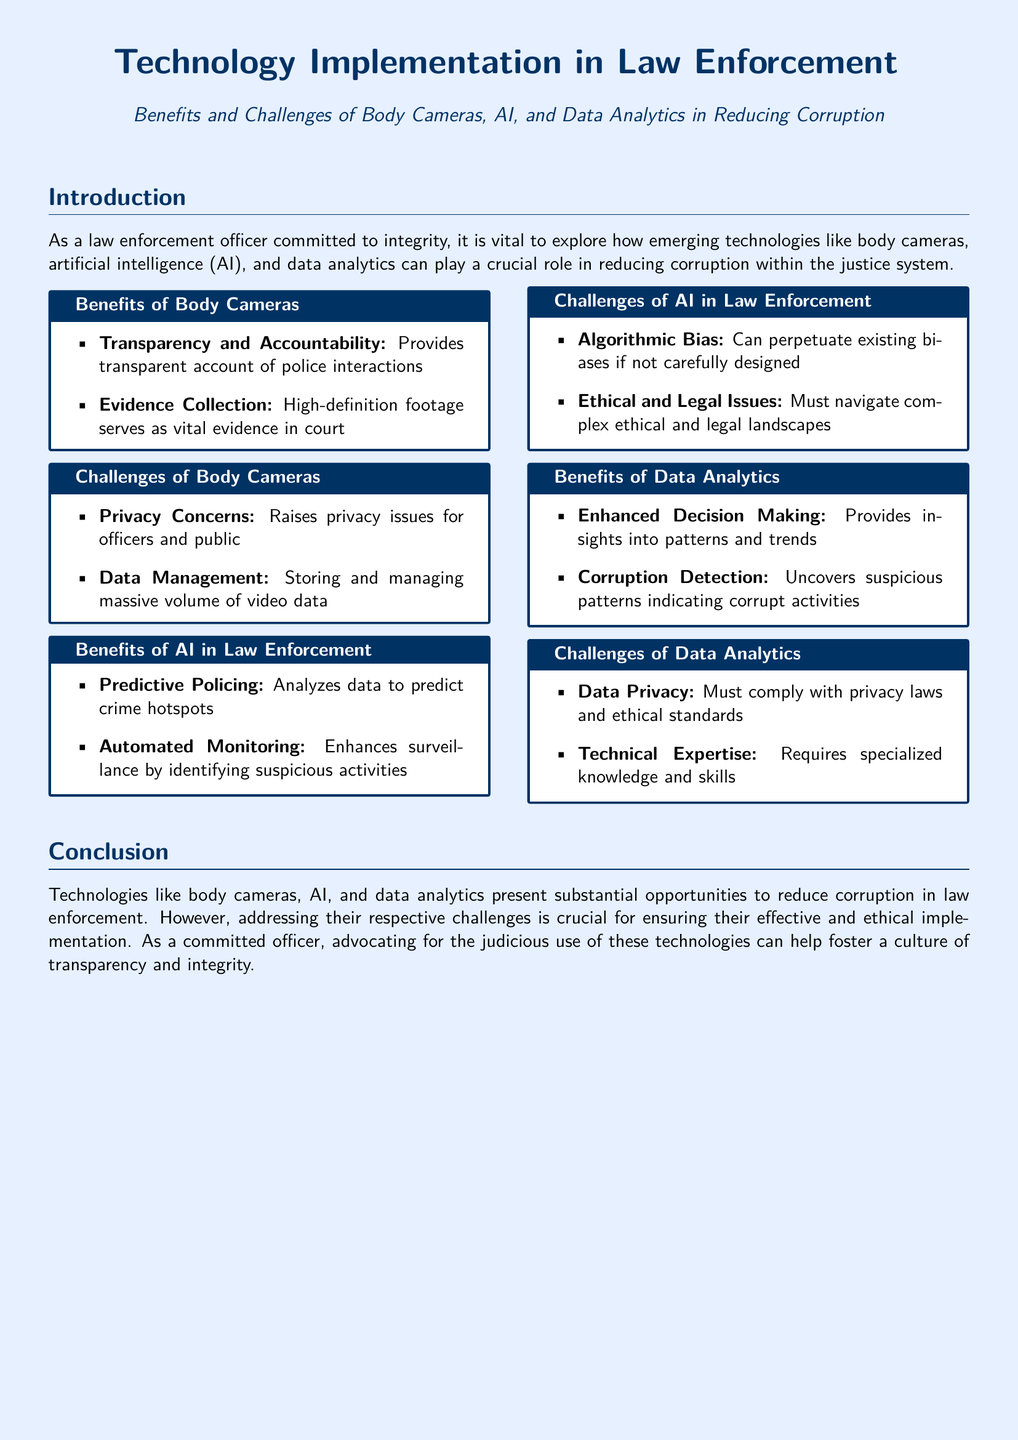What is the primary focus of the document? The document explores the role of emerging technologies in reducing corruption within law enforcement.
Answer: reducing corruption within law enforcement What is one benefit of body cameras? A benefit listed for body cameras is providing transparent accounts of police interactions.
Answer: Transparency and Accountability What challenge is associated with AI in law enforcement? The challenge mentioned for AI is its potential for algorithmic bias if not carefully designed.
Answer: Algorithmic Bias What does data analytics help uncover? Data analytics is noted for uncovering suspicious patterns indicating corrupt activities.
Answer: corrupt activities What ethical concern is raised about data analytics? The document states that data analytics must comply with privacy laws and ethical standards.
Answer: Data Privacy How many benefits of data analytics are listed in the document? The document lists two benefits of data analytics.
Answer: 2 What is one challenge of body cameras? A challenge highlighted for body cameras is the storage of massive volumes of video data.
Answer: Data Management What is a positive outcome of using predictive policing? Predictive policing analyzes data to predict crime hotspots.
Answer: predict crime hotspots What is the source of the document? The document is a fact sheet about technology implementation in law enforcement.
Answer: Fact sheet 